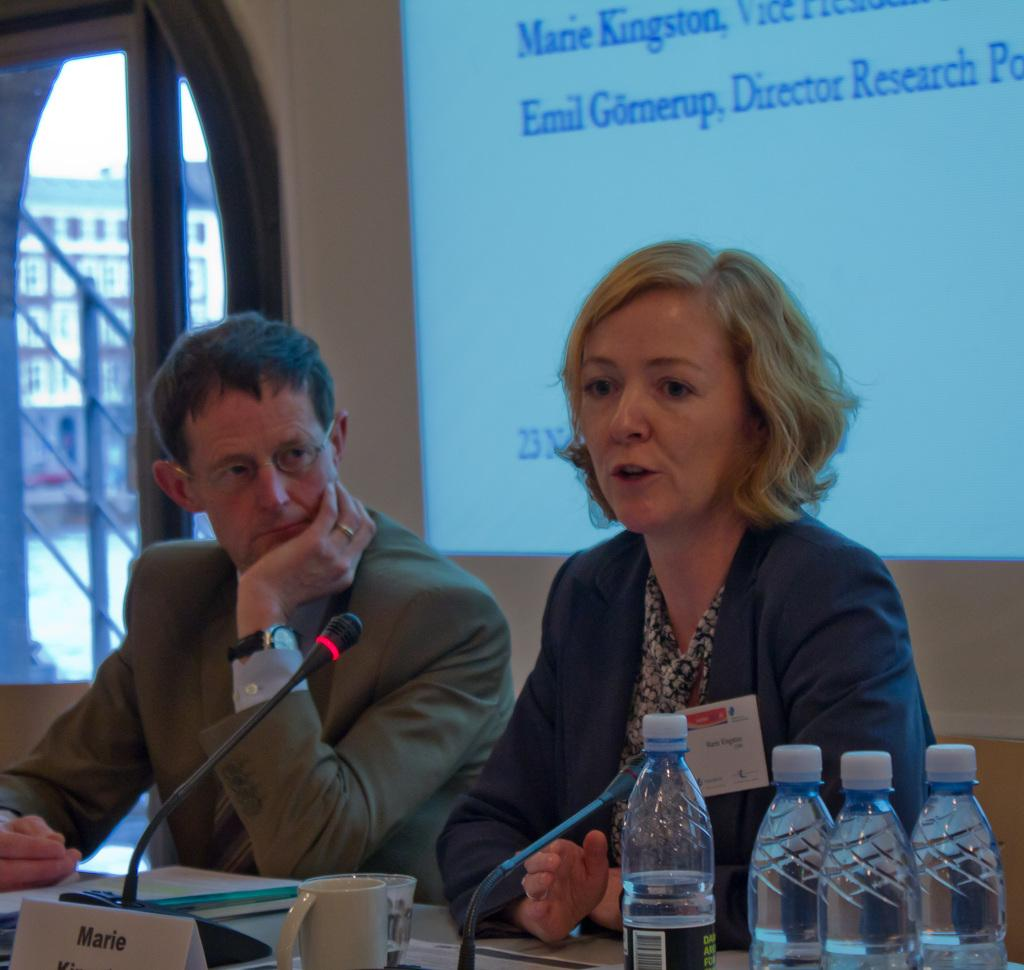What is the woman in the image doing? The woman is sitting in a chair and speaking. Who is beside the woman? There is a man beside the woman. What objects can be seen on the table in the image? There are microphones, a cup, and bottles on the table. What is visible behind the woman and the man? There is a screen behind the woman and the man. What type of creature is sitting on the pot in the image? There is no pot or creature present in the image. Is the woman driving a car in the image? No, the woman is sitting in a chair and speaking, not driving a car. 